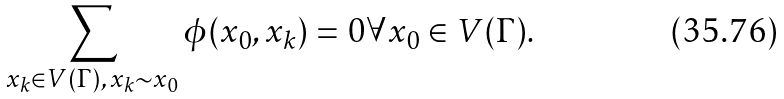<formula> <loc_0><loc_0><loc_500><loc_500>\sum _ { x _ { k } \in V ( \Gamma ) , \, x _ { k } \sim x _ { 0 } } \phi ( x _ { 0 } , x _ { k } ) = 0 \forall x _ { 0 } \in V ( \Gamma ) .</formula> 